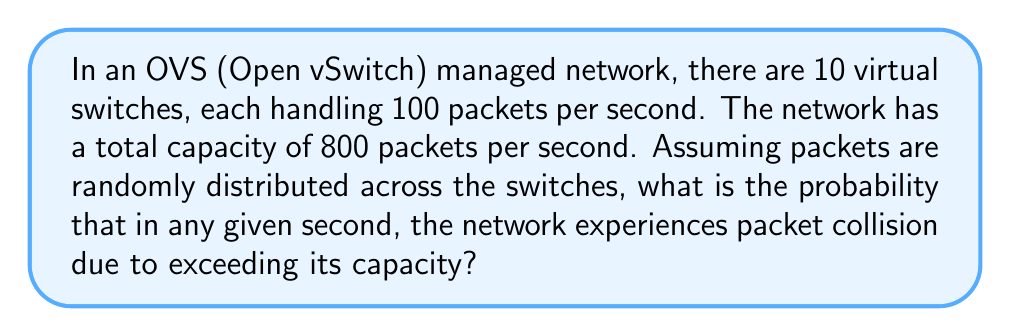Solve this math problem. Let's approach this step-by-step:

1) First, we need to calculate the total number of packets being handled per second:
   $10 \text{ switches} \times 100 \text{ packets/switch} = 1000 \text{ packets/second}$

2) The problem can be modeled as a binomial distribution, where each packet has a probability of being transmitted successfully or colliding.

3) The probability of a successful transmission for each packet is:
   $p = \frac{800}{1000} = 0.8$

4) The probability of a collision for each packet is:
   $q = 1 - p = 0.2$

5) We want to find the probability that more than 800 packets are transmitted, which is equivalent to the probability that 800 or fewer packets are not transmitted successfully.

6) We can use the cumulative binomial probability function:

   $$P(X > 800) = 1 - P(X \leq 800)$$

   where $X$ is the number of successfully transmitted packets.

7) Using the binomial probability formula:

   $$P(X \leq 800) = \sum_{k=0}^{800} \binom{1000}{k} (0.8)^k (0.2)^{1000-k}$$

8) This sum is computationally intensive, so we can use the normal approximation to the binomial distribution since $np$ and $nq$ are both greater than 5.

9) The mean of this normal distribution is:
   $\mu = np = 1000 \times 0.8 = 800$

10) The standard deviation is:
    $\sigma = \sqrt{npq} = \sqrt{1000 \times 0.8 \times 0.2} = \sqrt{160} = 12.65$

11) We can now use the z-score to standardize our value:
    $z = \frac{800.5 - 800}{12.65} = 0.0395$

   Note: We use 800.5 instead of 800 for continuity correction.

12) Using a standard normal distribution table or calculator, we can find:
    $P(Z \leq 0.0395) \approx 0.5158$

13) Therefore, the probability of packet collision is:
    $P(X > 800) = 1 - 0.5158 = 0.4842$
Answer: $0.4842$ 